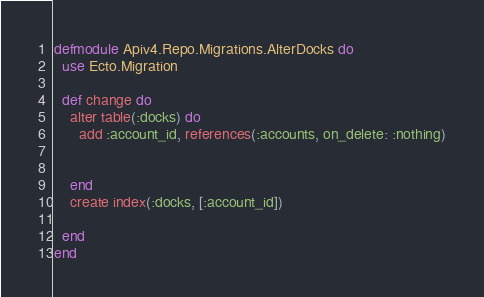<code> <loc_0><loc_0><loc_500><loc_500><_Elixir_>defmodule Apiv4.Repo.Migrations.AlterDocks do
  use Ecto.Migration

  def change do
    alter table(:docks) do
      add :account_id, references(:accounts, on_delete: :nothing)

      
    end
    create index(:docks, [:account_id])

  end
end</code> 